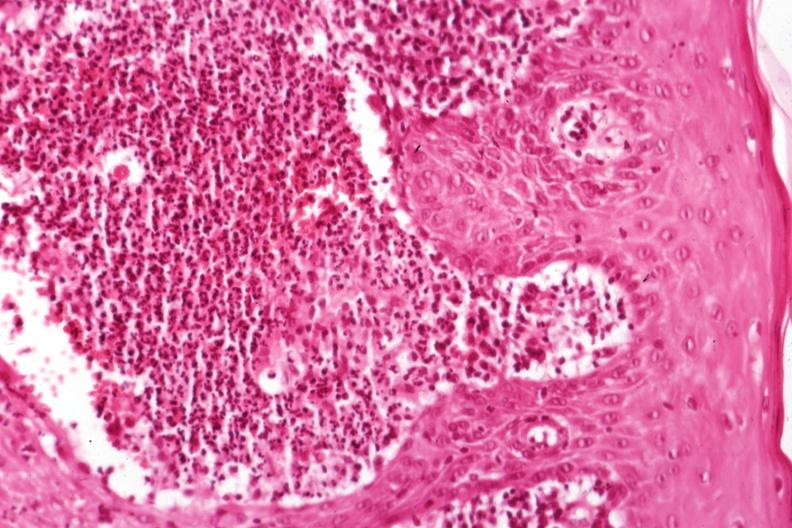what is present?
Answer the question using a single word or phrase. Sporotrichosis 